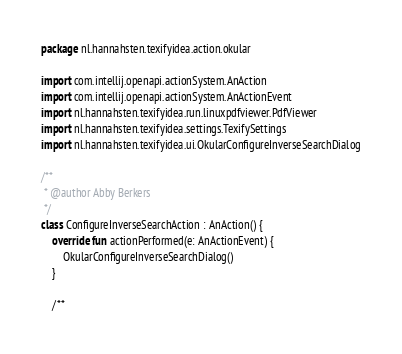<code> <loc_0><loc_0><loc_500><loc_500><_Kotlin_>package nl.hannahsten.texifyidea.action.okular

import com.intellij.openapi.actionSystem.AnAction
import com.intellij.openapi.actionSystem.AnActionEvent
import nl.hannahsten.texifyidea.run.linuxpdfviewer.PdfViewer
import nl.hannahsten.texifyidea.settings.TexifySettings
import nl.hannahsten.texifyidea.ui.OkularConfigureInverseSearchDialog

/**
 * @author Abby Berkers
 */
class ConfigureInverseSearchAction : AnAction() {
    override fun actionPerformed(e: AnActionEvent) {
        OkularConfigureInverseSearchDialog()
    }

    /**</code> 